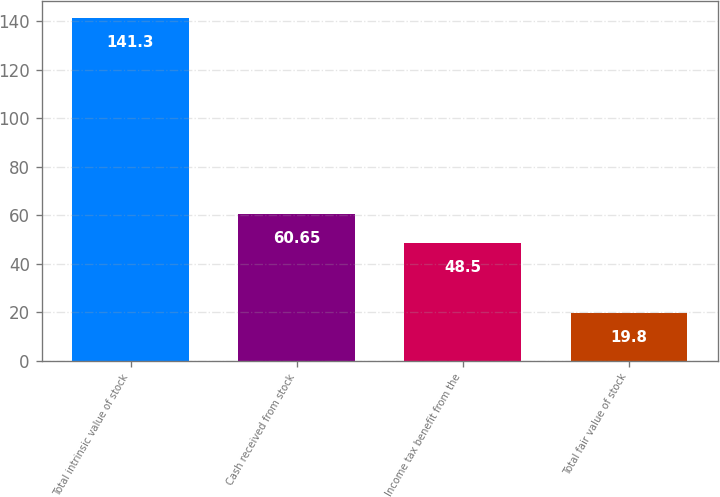<chart> <loc_0><loc_0><loc_500><loc_500><bar_chart><fcel>Total intrinsic value of stock<fcel>Cash received from stock<fcel>Income tax benefit from the<fcel>Total fair value of stock<nl><fcel>141.3<fcel>60.65<fcel>48.5<fcel>19.8<nl></chart> 